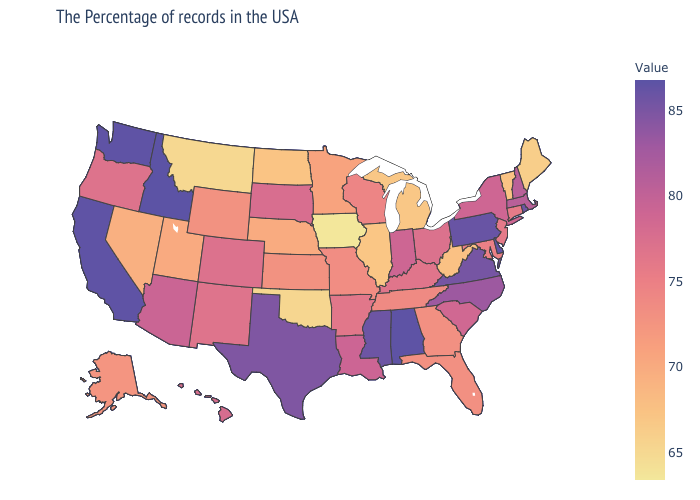Does the map have missing data?
Give a very brief answer. No. Does Massachusetts have a higher value than South Dakota?
Concise answer only. Yes. Among the states that border Minnesota , which have the lowest value?
Give a very brief answer. Iowa. Which states hav the highest value in the West?
Keep it brief. Idaho. Among the states that border Nevada , which have the lowest value?
Keep it brief. Utah. 